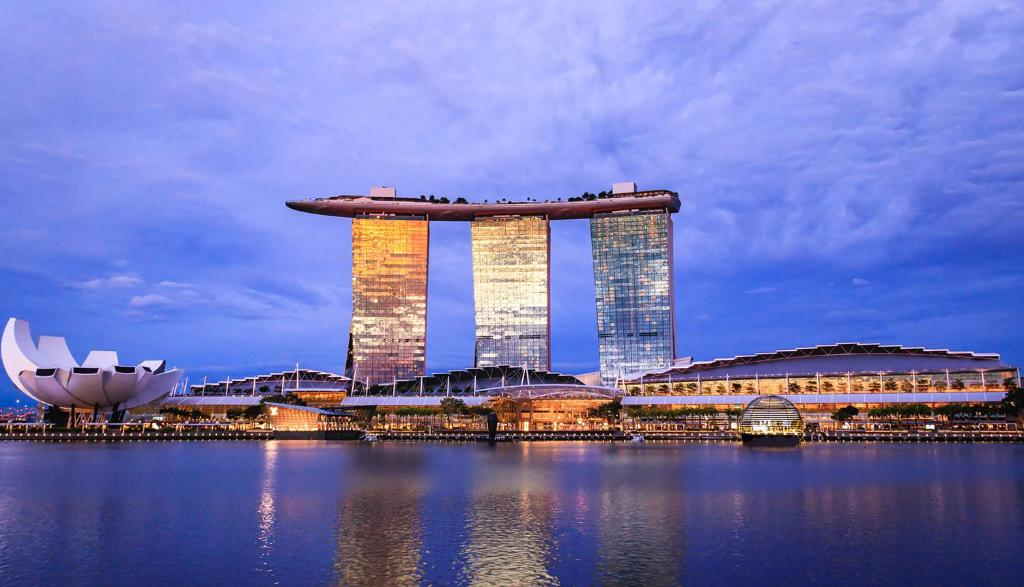What are the key elements in this picture? The image highlights the stunning Marina Bay Sands hotel in Singapore, a feat of modern design. It features three towering structures joined by a remarkable curved rooftop. This rooftop houses a unique infinity pool and park, offering a breathtaking panoramic view of the bustling cityscape. The hotel's facade is bathed in warm orange and cool blue lights, which beautifully reflect off the calm waters in the foreground. The serene blue sky, dotted with delicate clouds, serves as a perfect canvas for this architectural wonder. To the left, the ArtScience Museum stands out with its lotus flower-inspired design, complementing the futuristic skyline of Singapore. 